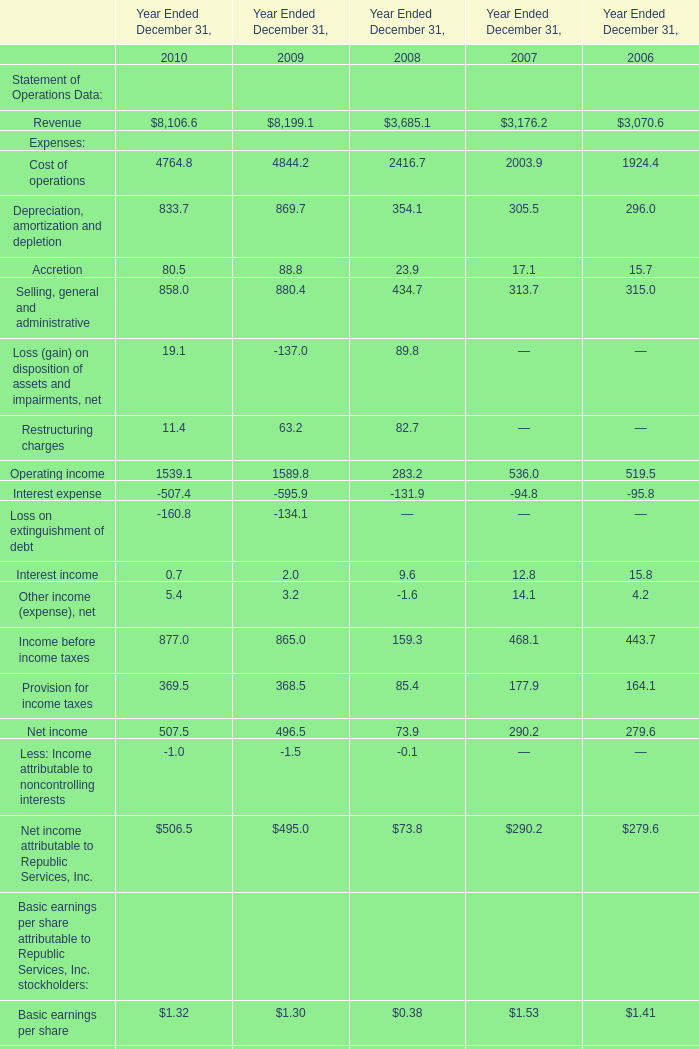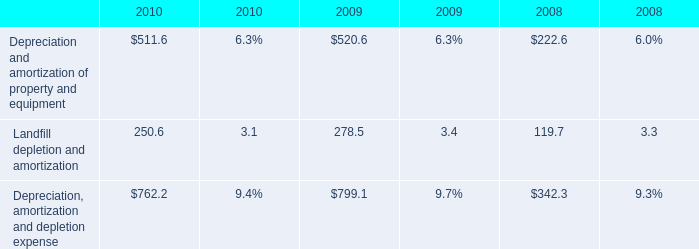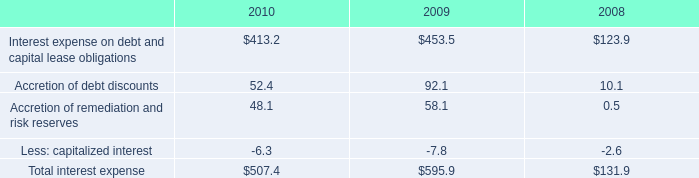What is the ratio of Accretion in Table 0 to the Accretion of debt discounts in Table 2 in 2009? 
Computations: (88.8 / 92.1)
Answer: 0.96417. 